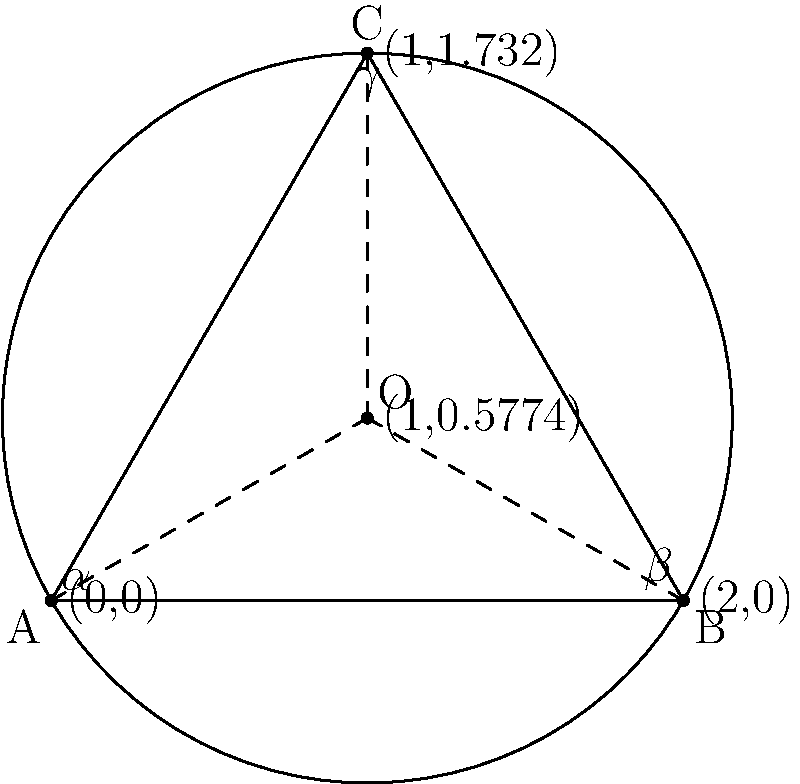In the diagram above, triangle ABC is inscribed in a circle with center O. The angles $\alpha$, $\beta$, and $\gamma$ represent three distinct musical movements in a composition. If $\alpha = 40°$ and $\beta = 50°$, what is the measure of $\gamma$? How does this relationship between inscribed angles reflect the interconnectedness of musical movements? To solve this problem, we'll follow these steps:

1. Recall the theorem for inscribed angles in a circle: The measure of an inscribed angle is half the measure of the central angle that subtends the same arc.

2. In a circle, the sum of the measures of the central angles is always 360°.

3. Let's denote the central angles corresponding to $\alpha$, $\beta$, and $\gamma$ as $2\alpha$, $2\beta$, and $2\gamma$ respectively.

4. We can write the equation:
   $$2\alpha + 2\beta + 2\gamma = 360°$$

5. Substitute the known values:
   $$2(40°) + 2(50°) + 2\gamma = 360°$$
   $$80° + 100° + 2\gamma = 360°$$
   $$180° + 2\gamma = 360°$$

6. Solve for $\gamma$:
   $$2\gamma = 360° - 180° = 180°$$
   $$\gamma = 90°$$

This relationship reflects the interconnectedness of musical movements because:

a) The sum of the inscribed angles is always 180°, just as different movements in a composition must come together to form a cohesive whole.

b) Changing one angle affects the others, similar to how altering one movement in a composition influences the overall structure and balance of the piece.

c) The circular nature of the diagram represents the cyclical and interrelated nature of musical themes and motifs across movements.
Answer: $\gamma = 90°$ 